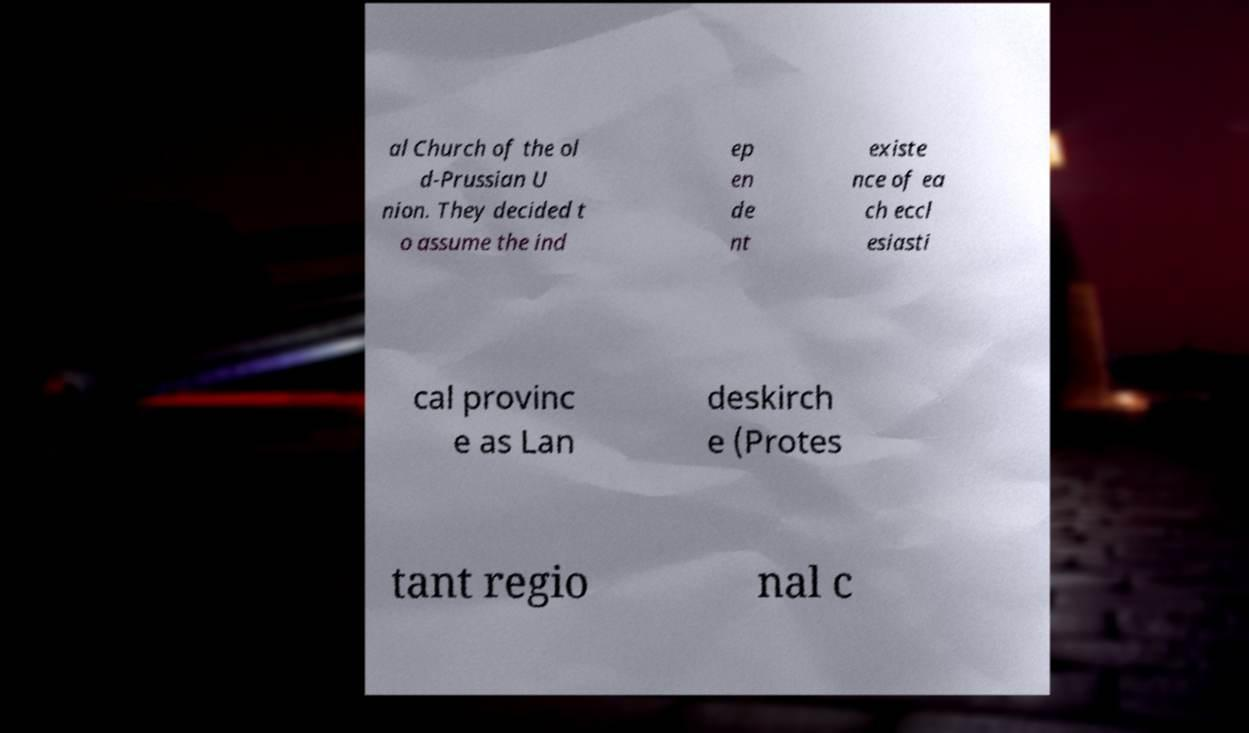Can you read and provide the text displayed in the image?This photo seems to have some interesting text. Can you extract and type it out for me? al Church of the ol d-Prussian U nion. They decided t o assume the ind ep en de nt existe nce of ea ch eccl esiasti cal provinc e as Lan deskirch e (Protes tant regio nal c 